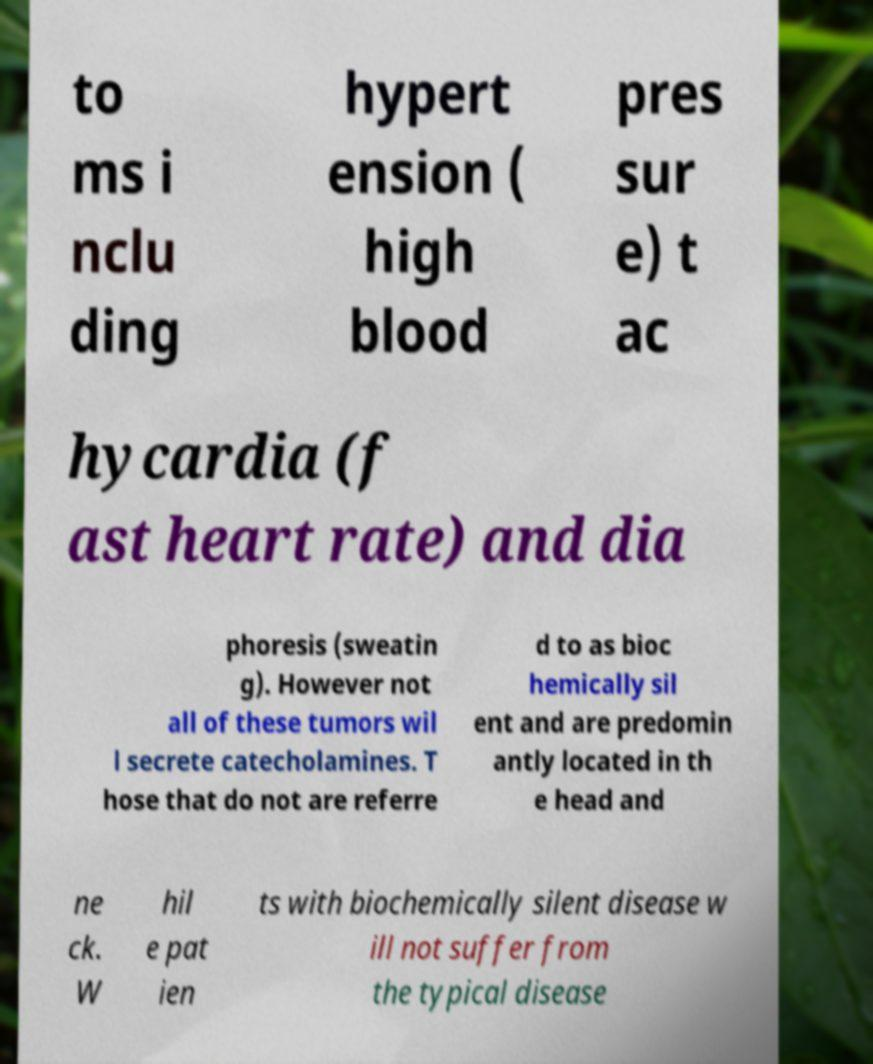I need the written content from this picture converted into text. Can you do that? to ms i nclu ding hypert ension ( high blood pres sur e) t ac hycardia (f ast heart rate) and dia phoresis (sweatin g). However not all of these tumors wil l secrete catecholamines. T hose that do not are referre d to as bioc hemically sil ent and are predomin antly located in th e head and ne ck. W hil e pat ien ts with biochemically silent disease w ill not suffer from the typical disease 